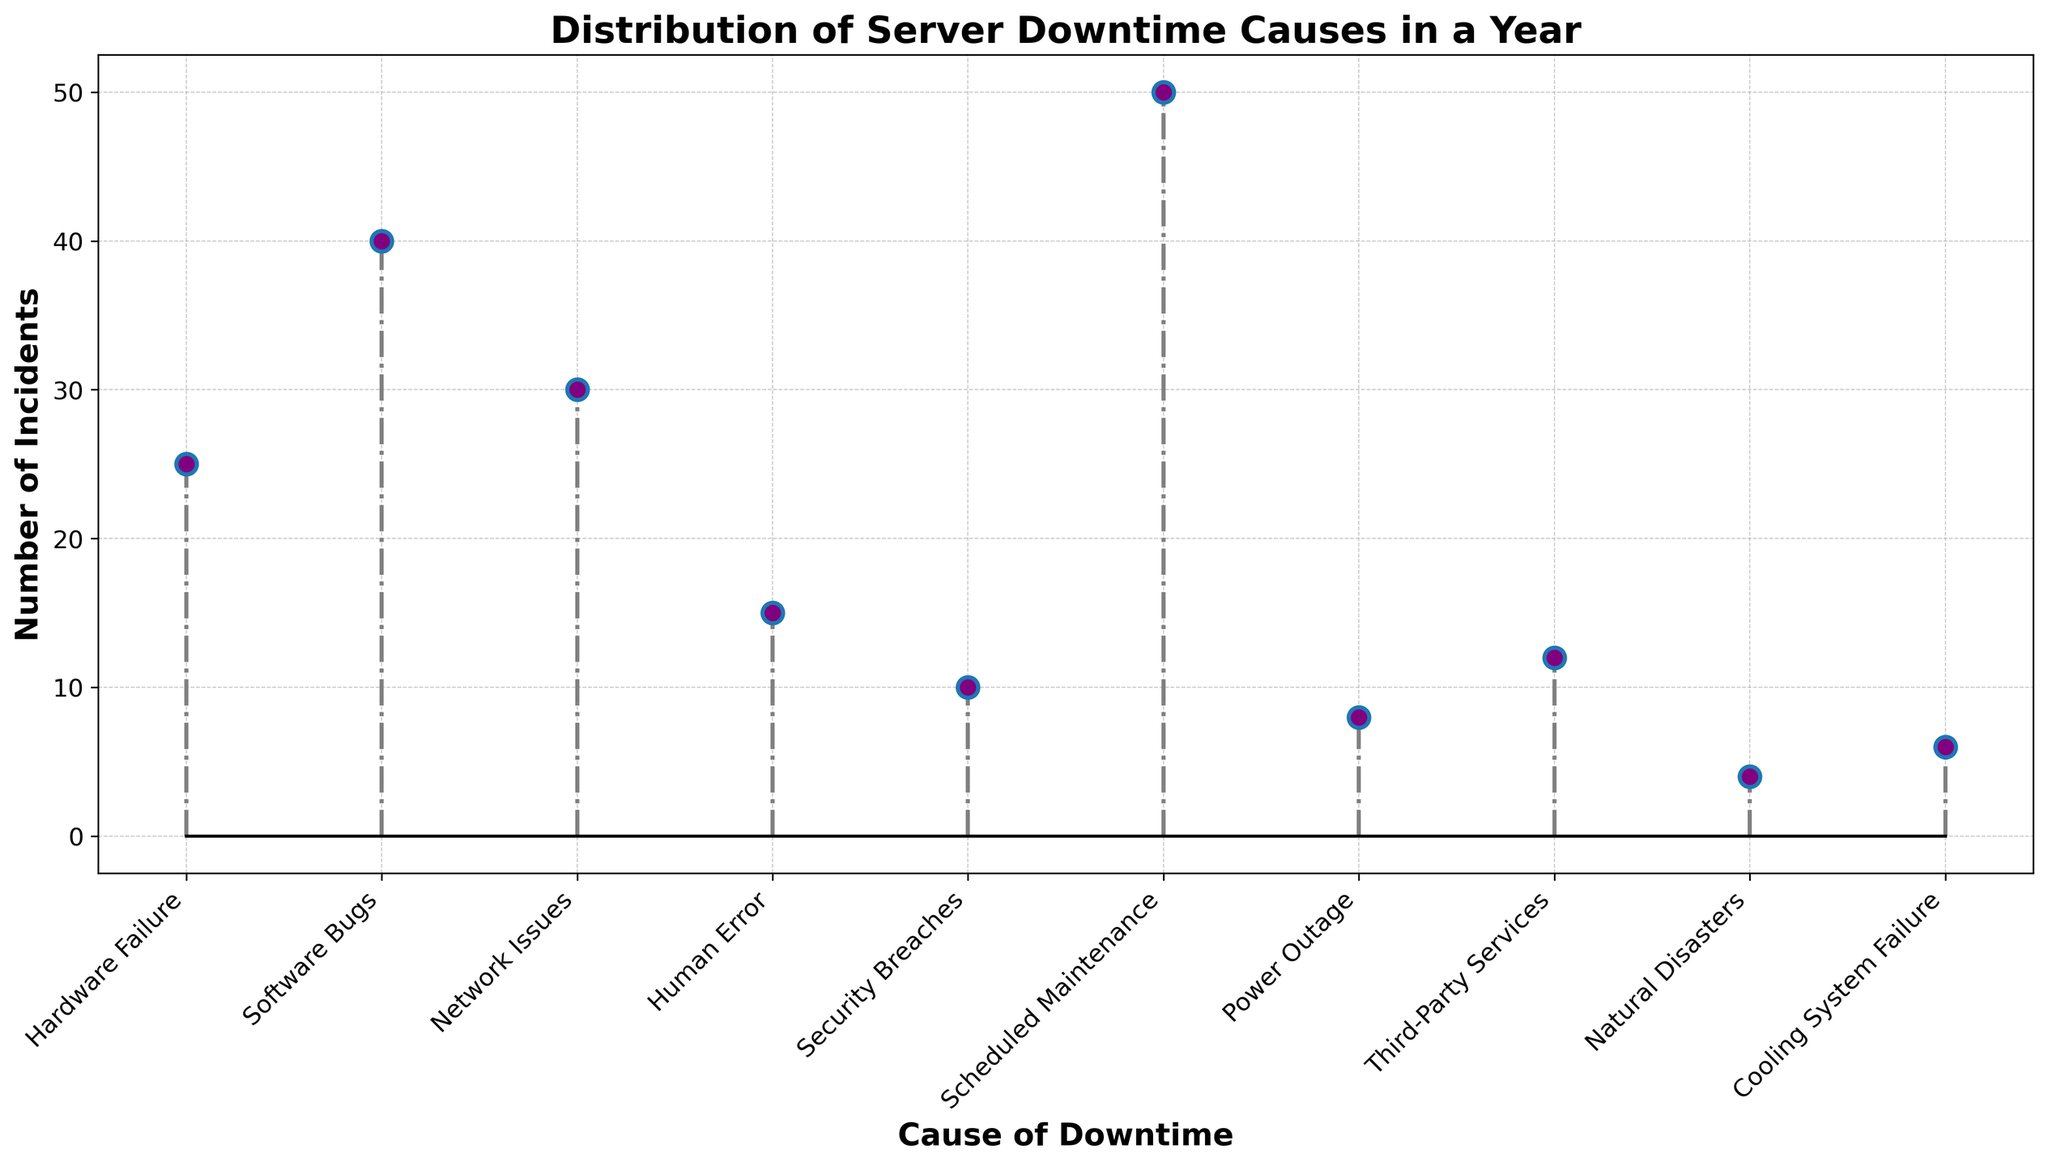What is the most common cause of server downtime? The most common cause of downtime is the one with the highest number of incidents. The figure shows that Scheduled Maintenance has the highest number of incidents.
Answer: Scheduled Maintenance What is the least common cause of server downtime? The least common cause of downtime is the one with the lowest number of incidents. The figure shows that Natural Disasters has the lowest number of incidents.
Answer: Natural Disasters How many incidents in total are caused by Hardware Failure and Software Bugs combined? To find the total number of incidents, add the incidents caused by Hardware Failure (25) and Software Bugs (40). 25 + 40 = 65
Answer: 65 Which cause has more incidents: Network Issues or Human Error? Compare the number of incidents for Network Issues (30) and Human Error (15). Network Issues has more incidents.
Answer: Network Issues What percentage of the total incidents is caused by Security Breaches? First, sum up the total incidents: 25 + 40 + 30 + 15 + 10 + 50 + 8 + 12 + 4 + 6 = 200. Then, calculate the percentage: (10 / 200) * 100 = 5%.
Answer: 5% Which causes have fewer than 10 incidents? Examine the figure for causes with incidents less than 10: Power Outage (8), Third-Party Services (12), Natural Disasters (4), Cooling System Failure (6). Exclude those over 10 incidents.
Answer: Power Outage, Natural Disasters, Cooling System Failure What is the difference in the number of incidents between Scheduled Maintenance and Cooling System Failure? Subtract the incidents of Cooling System Failure (6) from Scheduled Maintenance (50). 50 - 6 = 44
Answer: 44 How many more incidents does Hardware Failure have compared to Natural Disasters? Subtract the incidents of Natural Disasters (4) from Hardware Failure (25). 25 - 4 = 21
Answer: 21 